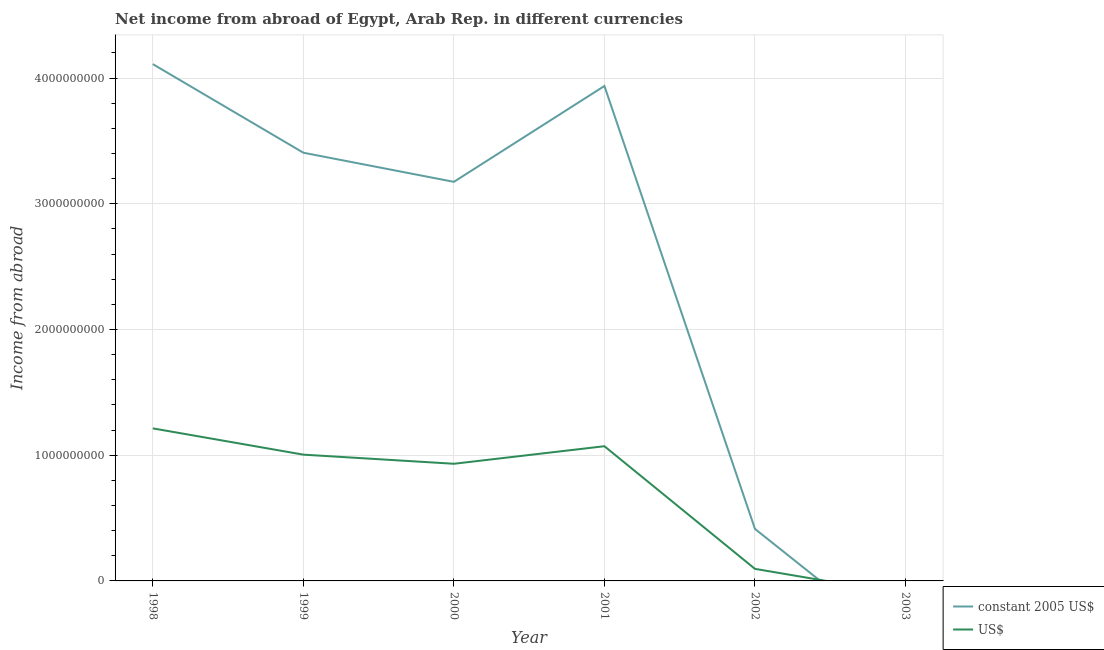What is the income from abroad in constant 2005 us$ in 1998?
Keep it short and to the point. 4.11e+09. Across all years, what is the maximum income from abroad in constant 2005 us$?
Offer a very short reply. 4.11e+09. What is the total income from abroad in constant 2005 us$ in the graph?
Provide a succinct answer. 1.50e+1. What is the difference between the income from abroad in us$ in 1998 and that in 2000?
Keep it short and to the point. 2.81e+08. What is the difference between the income from abroad in constant 2005 us$ in 2002 and the income from abroad in us$ in 2000?
Your answer should be compact. -5.18e+08. What is the average income from abroad in constant 2005 us$ per year?
Your answer should be very brief. 2.51e+09. In the year 1999, what is the difference between the income from abroad in constant 2005 us$ and income from abroad in us$?
Make the answer very short. 2.40e+09. What is the ratio of the income from abroad in us$ in 1998 to that in 2000?
Keep it short and to the point. 1.3. What is the difference between the highest and the second highest income from abroad in constant 2005 us$?
Give a very brief answer. 1.74e+08. What is the difference between the highest and the lowest income from abroad in us$?
Provide a short and direct response. 1.21e+09. In how many years, is the income from abroad in us$ greater than the average income from abroad in us$ taken over all years?
Ensure brevity in your answer.  4. Does the income from abroad in us$ monotonically increase over the years?
Your answer should be very brief. No. Is the income from abroad in constant 2005 us$ strictly greater than the income from abroad in us$ over the years?
Offer a very short reply. No. Is the income from abroad in us$ strictly less than the income from abroad in constant 2005 us$ over the years?
Your response must be concise. No. How many lines are there?
Make the answer very short. 2. How many years are there in the graph?
Provide a succinct answer. 6. What is the difference between two consecutive major ticks on the Y-axis?
Provide a succinct answer. 1.00e+09. Does the graph contain any zero values?
Your response must be concise. Yes. Does the graph contain grids?
Keep it short and to the point. Yes. What is the title of the graph?
Ensure brevity in your answer.  Net income from abroad of Egypt, Arab Rep. in different currencies. Does "Not attending school" appear as one of the legend labels in the graph?
Your answer should be very brief. No. What is the label or title of the X-axis?
Offer a very short reply. Year. What is the label or title of the Y-axis?
Give a very brief answer. Income from abroad. What is the Income from abroad of constant 2005 US$ in 1998?
Provide a short and direct response. 4.11e+09. What is the Income from abroad of US$ in 1998?
Offer a very short reply. 1.21e+09. What is the Income from abroad in constant 2005 US$ in 1999?
Provide a succinct answer. 3.41e+09. What is the Income from abroad in US$ in 1999?
Provide a succinct answer. 1.00e+09. What is the Income from abroad in constant 2005 US$ in 2000?
Your answer should be very brief. 3.17e+09. What is the Income from abroad in US$ in 2000?
Your response must be concise. 9.32e+08. What is the Income from abroad in constant 2005 US$ in 2001?
Offer a terse response. 3.94e+09. What is the Income from abroad of US$ in 2001?
Offer a very short reply. 1.07e+09. What is the Income from abroad of constant 2005 US$ in 2002?
Provide a succinct answer. 4.14e+08. What is the Income from abroad in US$ in 2002?
Offer a very short reply. 9.59e+07. Across all years, what is the maximum Income from abroad in constant 2005 US$?
Keep it short and to the point. 4.11e+09. Across all years, what is the maximum Income from abroad of US$?
Your answer should be very brief. 1.21e+09. Across all years, what is the minimum Income from abroad of US$?
Give a very brief answer. 0. What is the total Income from abroad of constant 2005 US$ in the graph?
Make the answer very short. 1.50e+1. What is the total Income from abroad of US$ in the graph?
Offer a very short reply. 4.32e+09. What is the difference between the Income from abroad in constant 2005 US$ in 1998 and that in 1999?
Offer a very short reply. 7.05e+08. What is the difference between the Income from abroad of US$ in 1998 and that in 1999?
Your answer should be compact. 2.09e+08. What is the difference between the Income from abroad of constant 2005 US$ in 1998 and that in 2000?
Offer a very short reply. 9.36e+08. What is the difference between the Income from abroad of US$ in 1998 and that in 2000?
Provide a short and direct response. 2.81e+08. What is the difference between the Income from abroad in constant 2005 US$ in 1998 and that in 2001?
Provide a short and direct response. 1.74e+08. What is the difference between the Income from abroad in US$ in 1998 and that in 2001?
Make the answer very short. 1.42e+08. What is the difference between the Income from abroad of constant 2005 US$ in 1998 and that in 2002?
Your answer should be compact. 3.70e+09. What is the difference between the Income from abroad of US$ in 1998 and that in 2002?
Give a very brief answer. 1.12e+09. What is the difference between the Income from abroad in constant 2005 US$ in 1999 and that in 2000?
Your answer should be very brief. 2.32e+08. What is the difference between the Income from abroad of US$ in 1999 and that in 2000?
Give a very brief answer. 7.26e+07. What is the difference between the Income from abroad in constant 2005 US$ in 1999 and that in 2001?
Provide a short and direct response. -5.31e+08. What is the difference between the Income from abroad in US$ in 1999 and that in 2001?
Offer a very short reply. -6.71e+07. What is the difference between the Income from abroad of constant 2005 US$ in 1999 and that in 2002?
Provide a short and direct response. 2.99e+09. What is the difference between the Income from abroad of US$ in 1999 and that in 2002?
Make the answer very short. 9.08e+08. What is the difference between the Income from abroad of constant 2005 US$ in 2000 and that in 2001?
Provide a short and direct response. -7.63e+08. What is the difference between the Income from abroad of US$ in 2000 and that in 2001?
Provide a short and direct response. -1.40e+08. What is the difference between the Income from abroad of constant 2005 US$ in 2000 and that in 2002?
Ensure brevity in your answer.  2.76e+09. What is the difference between the Income from abroad in US$ in 2000 and that in 2002?
Offer a very short reply. 8.36e+08. What is the difference between the Income from abroad of constant 2005 US$ in 2001 and that in 2002?
Your answer should be compact. 3.52e+09. What is the difference between the Income from abroad of US$ in 2001 and that in 2002?
Make the answer very short. 9.76e+08. What is the difference between the Income from abroad of constant 2005 US$ in 1998 and the Income from abroad of US$ in 1999?
Your response must be concise. 3.11e+09. What is the difference between the Income from abroad in constant 2005 US$ in 1998 and the Income from abroad in US$ in 2000?
Give a very brief answer. 3.18e+09. What is the difference between the Income from abroad of constant 2005 US$ in 1998 and the Income from abroad of US$ in 2001?
Provide a succinct answer. 3.04e+09. What is the difference between the Income from abroad in constant 2005 US$ in 1998 and the Income from abroad in US$ in 2002?
Your answer should be compact. 4.01e+09. What is the difference between the Income from abroad of constant 2005 US$ in 1999 and the Income from abroad of US$ in 2000?
Offer a very short reply. 2.47e+09. What is the difference between the Income from abroad in constant 2005 US$ in 1999 and the Income from abroad in US$ in 2001?
Your answer should be compact. 2.33e+09. What is the difference between the Income from abroad in constant 2005 US$ in 1999 and the Income from abroad in US$ in 2002?
Provide a short and direct response. 3.31e+09. What is the difference between the Income from abroad of constant 2005 US$ in 2000 and the Income from abroad of US$ in 2001?
Make the answer very short. 2.10e+09. What is the difference between the Income from abroad in constant 2005 US$ in 2000 and the Income from abroad in US$ in 2002?
Offer a very short reply. 3.08e+09. What is the difference between the Income from abroad of constant 2005 US$ in 2001 and the Income from abroad of US$ in 2002?
Ensure brevity in your answer.  3.84e+09. What is the average Income from abroad of constant 2005 US$ per year?
Offer a terse response. 2.51e+09. What is the average Income from abroad of US$ per year?
Your answer should be compact. 7.19e+08. In the year 1998, what is the difference between the Income from abroad in constant 2005 US$ and Income from abroad in US$?
Offer a very short reply. 2.90e+09. In the year 1999, what is the difference between the Income from abroad of constant 2005 US$ and Income from abroad of US$?
Your answer should be compact. 2.40e+09. In the year 2000, what is the difference between the Income from abroad in constant 2005 US$ and Income from abroad in US$?
Your answer should be very brief. 2.24e+09. In the year 2001, what is the difference between the Income from abroad in constant 2005 US$ and Income from abroad in US$?
Make the answer very short. 2.87e+09. In the year 2002, what is the difference between the Income from abroad in constant 2005 US$ and Income from abroad in US$?
Your response must be concise. 3.18e+08. What is the ratio of the Income from abroad of constant 2005 US$ in 1998 to that in 1999?
Make the answer very short. 1.21. What is the ratio of the Income from abroad in US$ in 1998 to that in 1999?
Your answer should be very brief. 1.21. What is the ratio of the Income from abroad of constant 2005 US$ in 1998 to that in 2000?
Offer a terse response. 1.29. What is the ratio of the Income from abroad of US$ in 1998 to that in 2000?
Offer a terse response. 1.3. What is the ratio of the Income from abroad in constant 2005 US$ in 1998 to that in 2001?
Keep it short and to the point. 1.04. What is the ratio of the Income from abroad of US$ in 1998 to that in 2001?
Provide a short and direct response. 1.13. What is the ratio of the Income from abroad in constant 2005 US$ in 1998 to that in 2002?
Offer a very short reply. 9.93. What is the ratio of the Income from abroad of US$ in 1998 to that in 2002?
Offer a terse response. 12.65. What is the ratio of the Income from abroad in constant 2005 US$ in 1999 to that in 2000?
Give a very brief answer. 1.07. What is the ratio of the Income from abroad of US$ in 1999 to that in 2000?
Keep it short and to the point. 1.08. What is the ratio of the Income from abroad of constant 2005 US$ in 1999 to that in 2001?
Offer a terse response. 0.87. What is the ratio of the Income from abroad in US$ in 1999 to that in 2001?
Ensure brevity in your answer.  0.94. What is the ratio of the Income from abroad in constant 2005 US$ in 1999 to that in 2002?
Keep it short and to the point. 8.23. What is the ratio of the Income from abroad of US$ in 1999 to that in 2002?
Your response must be concise. 10.47. What is the ratio of the Income from abroad in constant 2005 US$ in 2000 to that in 2001?
Ensure brevity in your answer.  0.81. What is the ratio of the Income from abroad of US$ in 2000 to that in 2001?
Offer a terse response. 0.87. What is the ratio of the Income from abroad in constant 2005 US$ in 2000 to that in 2002?
Provide a succinct answer. 7.67. What is the ratio of the Income from abroad in US$ in 2000 to that in 2002?
Provide a short and direct response. 9.71. What is the ratio of the Income from abroad in constant 2005 US$ in 2001 to that in 2002?
Your response must be concise. 9.51. What is the ratio of the Income from abroad of US$ in 2001 to that in 2002?
Keep it short and to the point. 11.17. What is the difference between the highest and the second highest Income from abroad in constant 2005 US$?
Your answer should be very brief. 1.74e+08. What is the difference between the highest and the second highest Income from abroad of US$?
Provide a succinct answer. 1.42e+08. What is the difference between the highest and the lowest Income from abroad of constant 2005 US$?
Give a very brief answer. 4.11e+09. What is the difference between the highest and the lowest Income from abroad in US$?
Make the answer very short. 1.21e+09. 